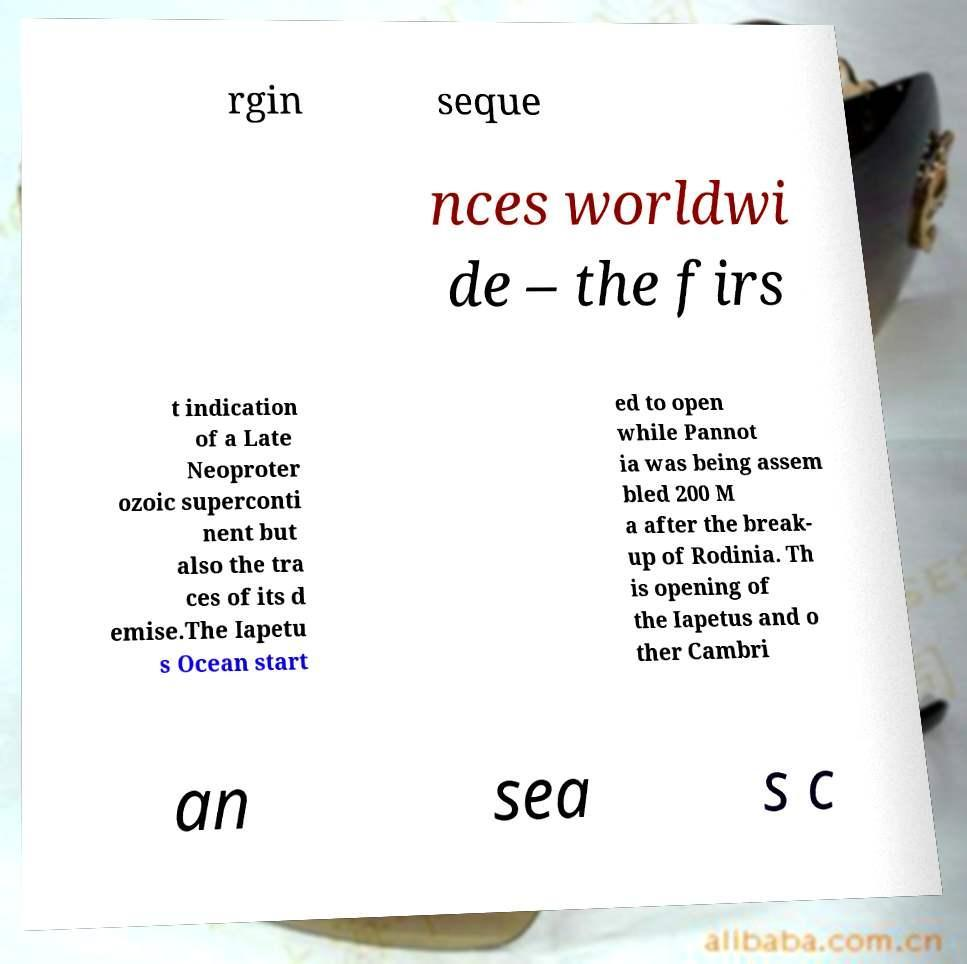Can you read and provide the text displayed in the image?This photo seems to have some interesting text. Can you extract and type it out for me? rgin seque nces worldwi de – the firs t indication of a Late Neoproter ozoic superconti nent but also the tra ces of its d emise.The Iapetu s Ocean start ed to open while Pannot ia was being assem bled 200 M a after the break- up of Rodinia. Th is opening of the Iapetus and o ther Cambri an sea s c 